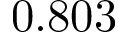Convert formula to latex. <formula><loc_0><loc_0><loc_500><loc_500>0 . 8 0 3</formula> 